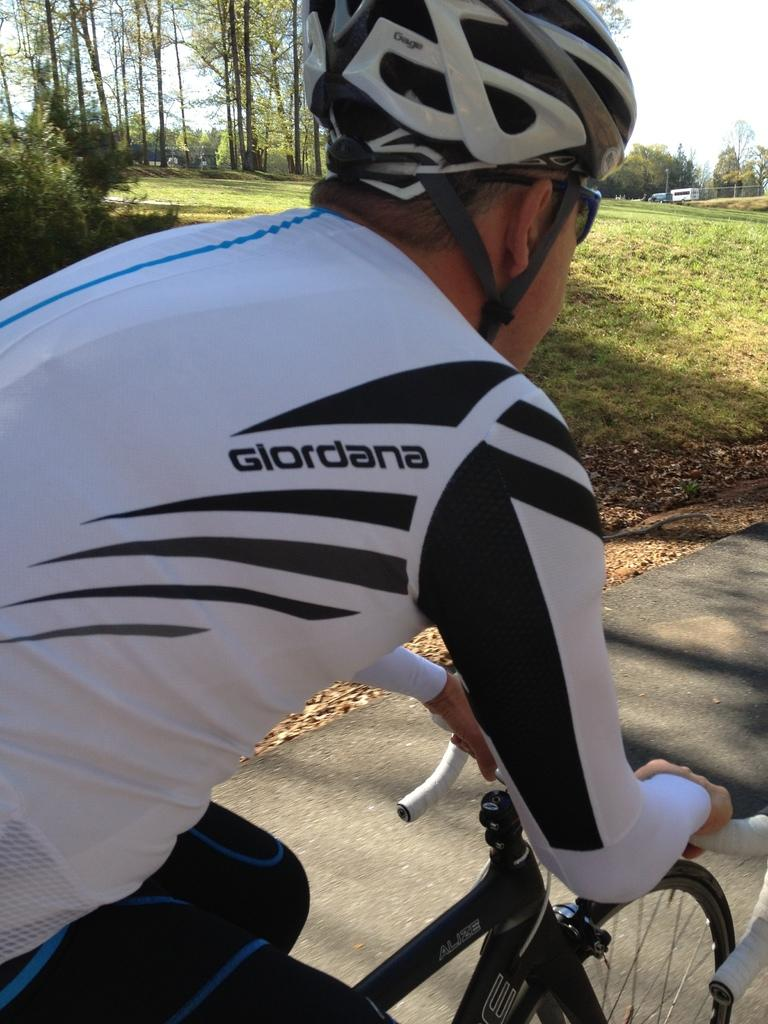Who is the person in the image? There is a man in the image. What is the man wearing on his upper body? The man is wearing a white t-shirt. What protective gear is the man wearing? The man is wearing a helmet. What is the man doing in the image? The man is riding a bicycle. Where is the bicycle located? The bicycle is on the road. What can be seen in the background of the image? There are many trees behind the man, and there is grass on the ground. How does the man measure the distance between the trees in the image? There is no indication in the image that the man is measuring anything, and no measuring tools are visible. 